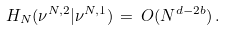<formula> <loc_0><loc_0><loc_500><loc_500>H _ { N } ( \nu ^ { N , 2 } | \nu ^ { N , 1 } ) \, = \, O ( N ^ { d - 2 b } ) \, .</formula> 